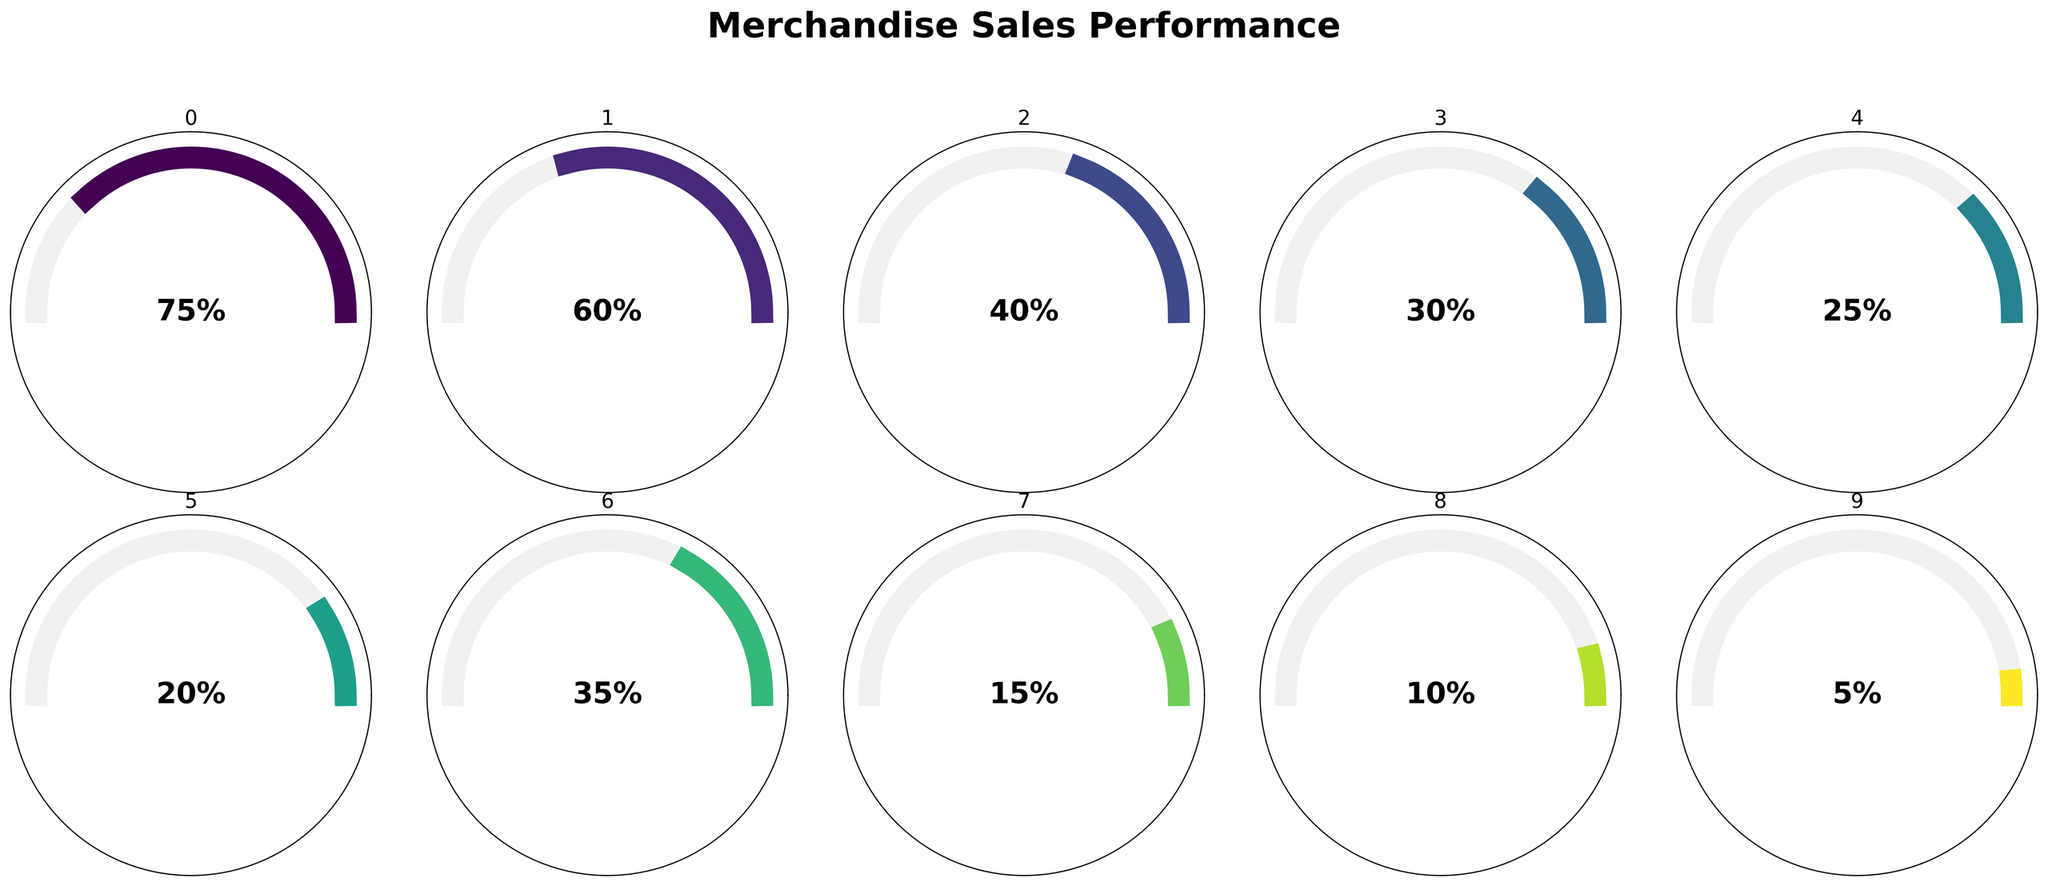What is the sales percentage for T-Shirts? The gauge chart for T-Shirts indicates that the needle is pointing at 75% on the gauge.
Answer: 75% Which item has the lowest sales percentage? By inspecting all the gauge charts, the item with the lowest sales percentage is Stickers, as the needle is pointing at 5%.
Answer: Stickers How much higher are the sales percentages of T-Shirts compared to Beanies? The sales percentage for T-Shirts is 75% and for Beanies, it is 15%. Subtracting these values, 75% - 15% = 60%.
Answer: 60% What is the average sales percentage of CDs, Posters, and Vinyl Records? The sales percentages are 40% for CDs, 30% for Posters, and 35% for Vinyl Records. Adding these values, 40% + 30% + 35% = 105%. Dividing by the number of items: 105% / 3 = 35%.
Answer: 35% Which items have sales percentages above 50%? By looking at the gauge charts, T-Shirts (75%) and Hoodies (60%) both have sales percentages above 50%.
Answer: T-Shirts, Hoodies How does the sales performance of Hoodies compare to Guitar Picks? Hoodies have a sales percentage of 60%, while Guitar Picks have a percentage of 20%. The difference is 60% - 20% = 40%.
Answer: 40% What’s the sales range (highest to lowest) among all the items? The highest sales percentage is for T-Shirts at 75%, and the lowest is for Stickers at 5%. The range is 75% - 5% = 70%.
Answer: 70% Is the sales percentage of Patches closer to that of Posters or CDs? Patches have a sales percentage of 25%, Posters have 30%, and CDs have 40%. The difference between Patches and Posters is 5% (30% - 25%), and the difference between Patches and CDs is 15% (40% - 25%). Therefore, Patches are closer to Posters.
Answer: Posters What is the total sales percentage for Wristbands and Stickers combined? Wristbands have a sales percentage of 10%, and Stickers have 5%. Adding these up: 10% + 5% = 15%.
Answer: 15% Which item with a sales percentage below 50% has the highest value, and what is the percentage? Looking at the items with sales percentages below 50%, the highest value is for Vinyl Records, which have a sales percentage of 35%.
Answer: Vinyl Records, 35% 